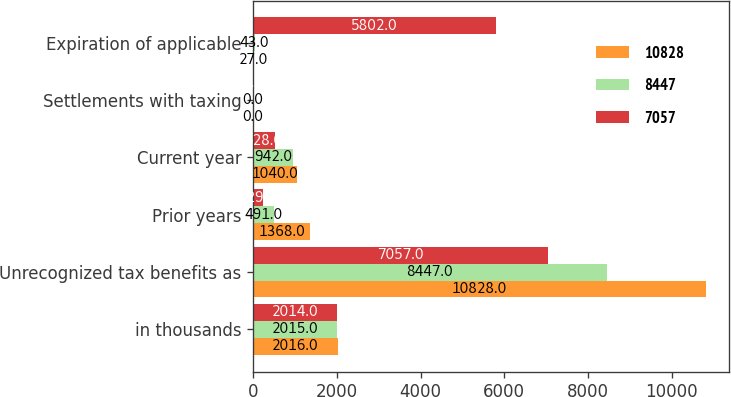<chart> <loc_0><loc_0><loc_500><loc_500><stacked_bar_chart><ecel><fcel>in thousands<fcel>Unrecognized tax benefits as<fcel>Prior years<fcel>Current year<fcel>Settlements with taxing<fcel>Expiration of applicable<nl><fcel>10828<fcel>2016<fcel>10828<fcel>1368<fcel>1040<fcel>0<fcel>27<nl><fcel>8447<fcel>2015<fcel>8447<fcel>491<fcel>942<fcel>0<fcel>43<nl><fcel>7057<fcel>2014<fcel>7057<fcel>229<fcel>528<fcel>0<fcel>5802<nl></chart> 